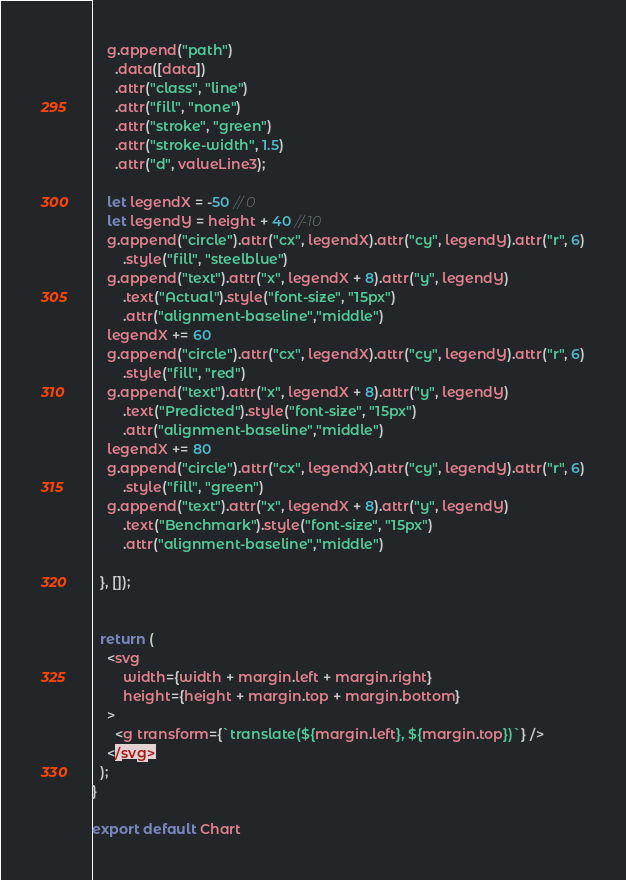<code> <loc_0><loc_0><loc_500><loc_500><_JavaScript_>
    g.append("path")
      .data([data])
      .attr("class", "line")
      .attr("fill", "none")
      .attr("stroke", "green")
      .attr("stroke-width", 1.5)
      .attr("d", valueLine3);

    let legendX = -50 // 0
    let legendY = height + 40 //-10
    g.append("circle").attr("cx", legendX).attr("cy", legendY).attr("r", 6)
        .style("fill", "steelblue")
    g.append("text").attr("x", legendX + 8).attr("y", legendY)
        .text("Actual").style("font-size", "15px")
        .attr("alignment-baseline","middle")
    legendX += 60
    g.append("circle").attr("cx", legendX).attr("cy", legendY).attr("r", 6)
        .style("fill", "red")
    g.append("text").attr("x", legendX + 8).attr("y", legendY)
        .text("Predicted").style("font-size", "15px")
        .attr("alignment-baseline","middle")
    legendX += 80
    g.append("circle").attr("cx", legendX).attr("cy", legendY).attr("r", 6)
        .style("fill", "green")
    g.append("text").attr("x", legendX + 8).attr("y", legendY)
        .text("Benchmark").style("font-size", "15px")
        .attr("alignment-baseline","middle")

  }, []);


  return (
    <svg
        width={width + margin.left + margin.right}
        height={height + margin.top + margin.bottom}
    >
      <g transform={`translate(${margin.left}, ${margin.top})`} />
    </svg>
  );
}

export default Chart</code> 